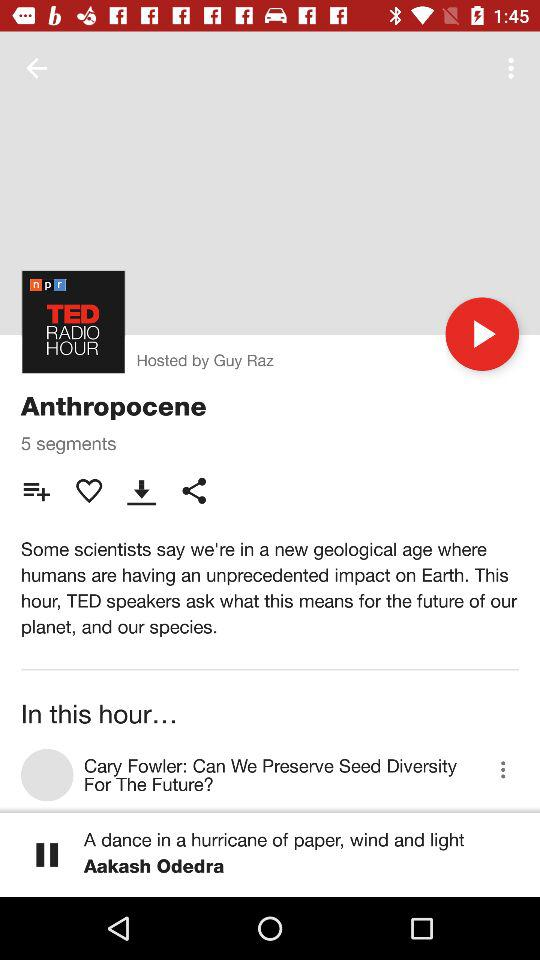What is the title of the show? The title of the show is "Anthropocene". 